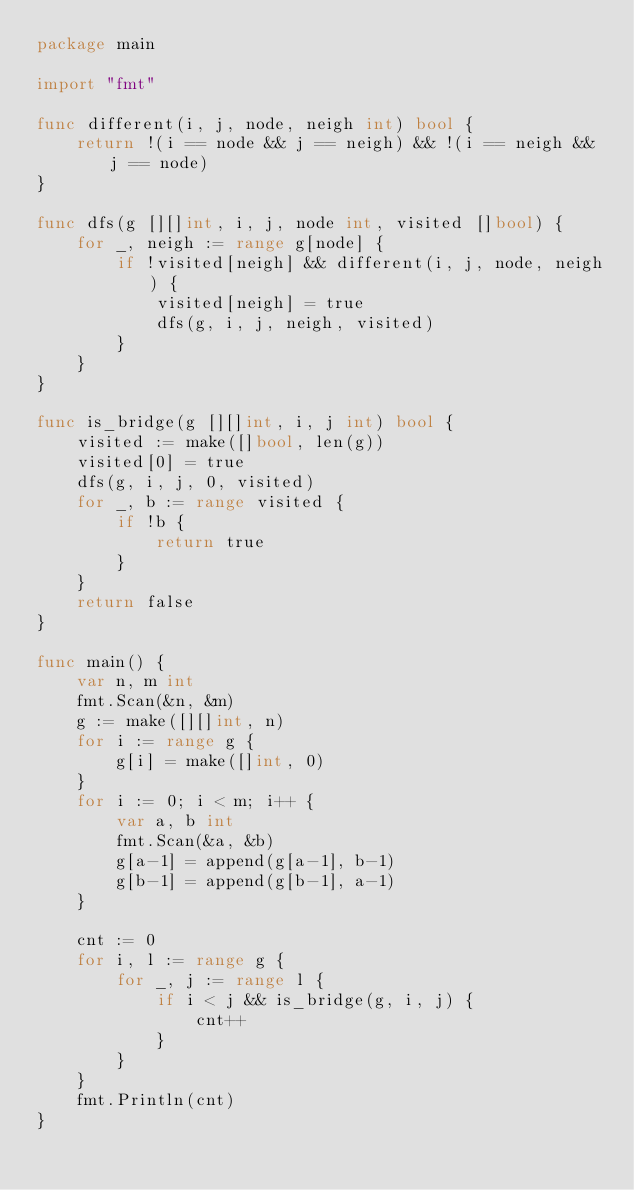Convert code to text. <code><loc_0><loc_0><loc_500><loc_500><_Go_>package main

import "fmt"

func different(i, j, node, neigh int) bool {
	return !(i == node && j == neigh) && !(i == neigh && j == node)
}

func dfs(g [][]int, i, j, node int, visited []bool) {
	for _, neigh := range g[node] {
		if !visited[neigh] && different(i, j, node, neigh) {
			visited[neigh] = true
			dfs(g, i, j, neigh, visited)
		}
	}
}

func is_bridge(g [][]int, i, j int) bool {
	visited := make([]bool, len(g))
	visited[0] = true
	dfs(g, i, j, 0, visited)
	for _, b := range visited {
		if !b {
			return true
		}
	}
	return false
}

func main() {
	var n, m int
	fmt.Scan(&n, &m)
	g := make([][]int, n)
	for i := range g {
		g[i] = make([]int, 0)
	}
	for i := 0; i < m; i++ {
		var a, b int
		fmt.Scan(&a, &b)
		g[a-1] = append(g[a-1], b-1)
		g[b-1] = append(g[b-1], a-1)
	}

	cnt := 0
	for i, l := range g {
		for _, j := range l {
			if i < j && is_bridge(g, i, j) {
				cnt++
			}
		}
	}
	fmt.Println(cnt)
}
</code> 